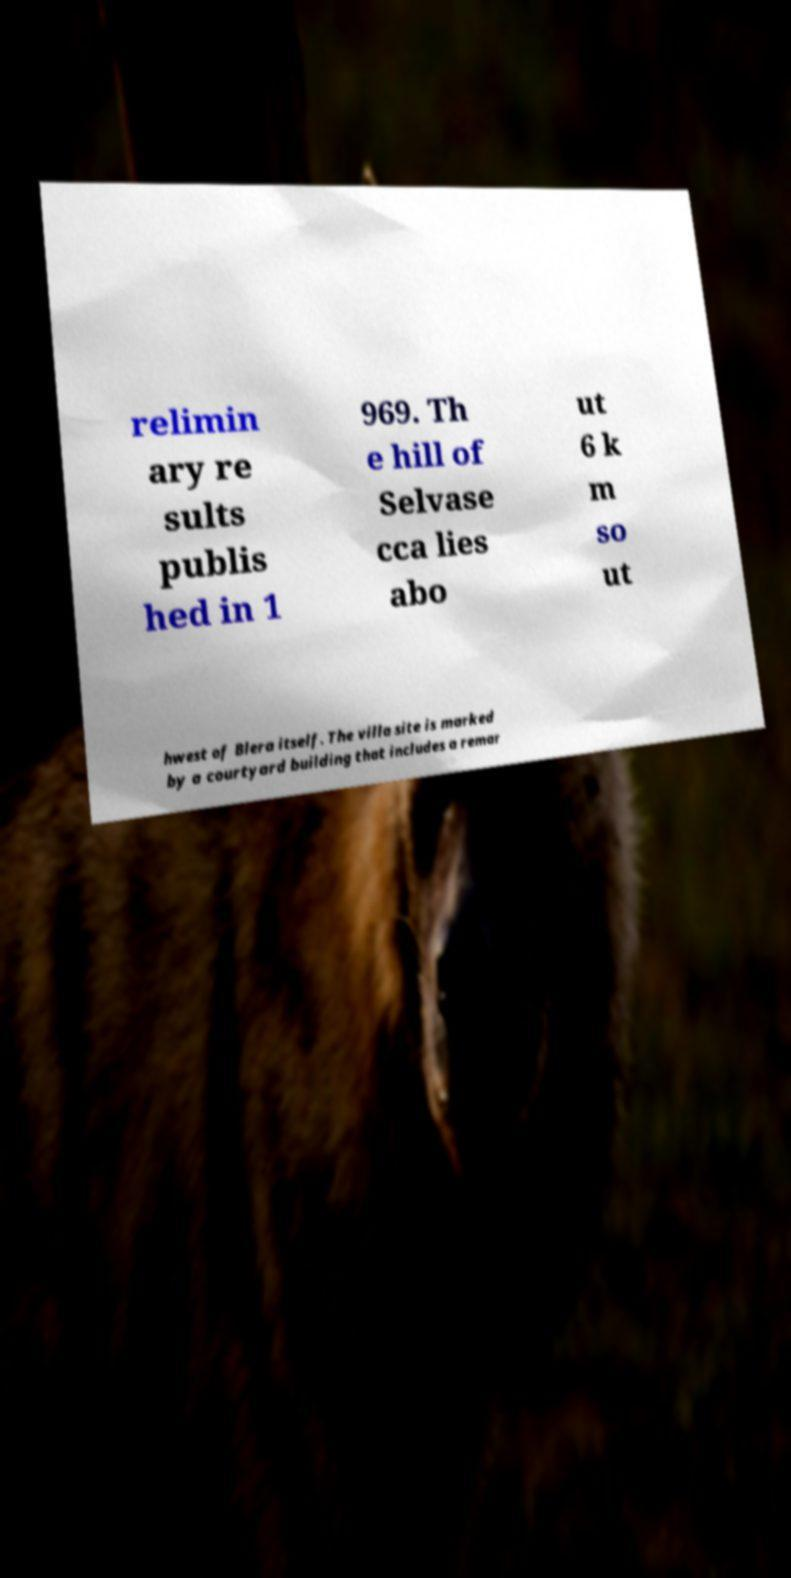For documentation purposes, I need the text within this image transcribed. Could you provide that? relimin ary re sults publis hed in 1 969. Th e hill of Selvase cca lies abo ut 6 k m so ut hwest of Blera itself. The villa site is marked by a courtyard building that includes a remar 